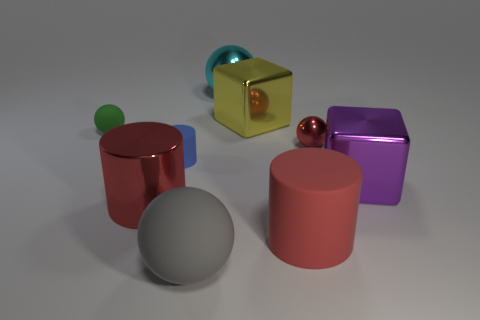Subtract all big cylinders. How many cylinders are left? 1 Subtract all yellow blocks. How many blocks are left? 1 Subtract 3 cylinders. How many cylinders are left? 0 Subtract all green cubes. Subtract all yellow spheres. How many cubes are left? 2 Subtract all red cubes. How many blue spheres are left? 0 Subtract all tiny green balls. Subtract all large yellow shiny things. How many objects are left? 7 Add 9 small cylinders. How many small cylinders are left? 10 Add 9 large cyan metal objects. How many large cyan metal objects exist? 10 Subtract 0 cyan blocks. How many objects are left? 9 Subtract all cylinders. How many objects are left? 6 